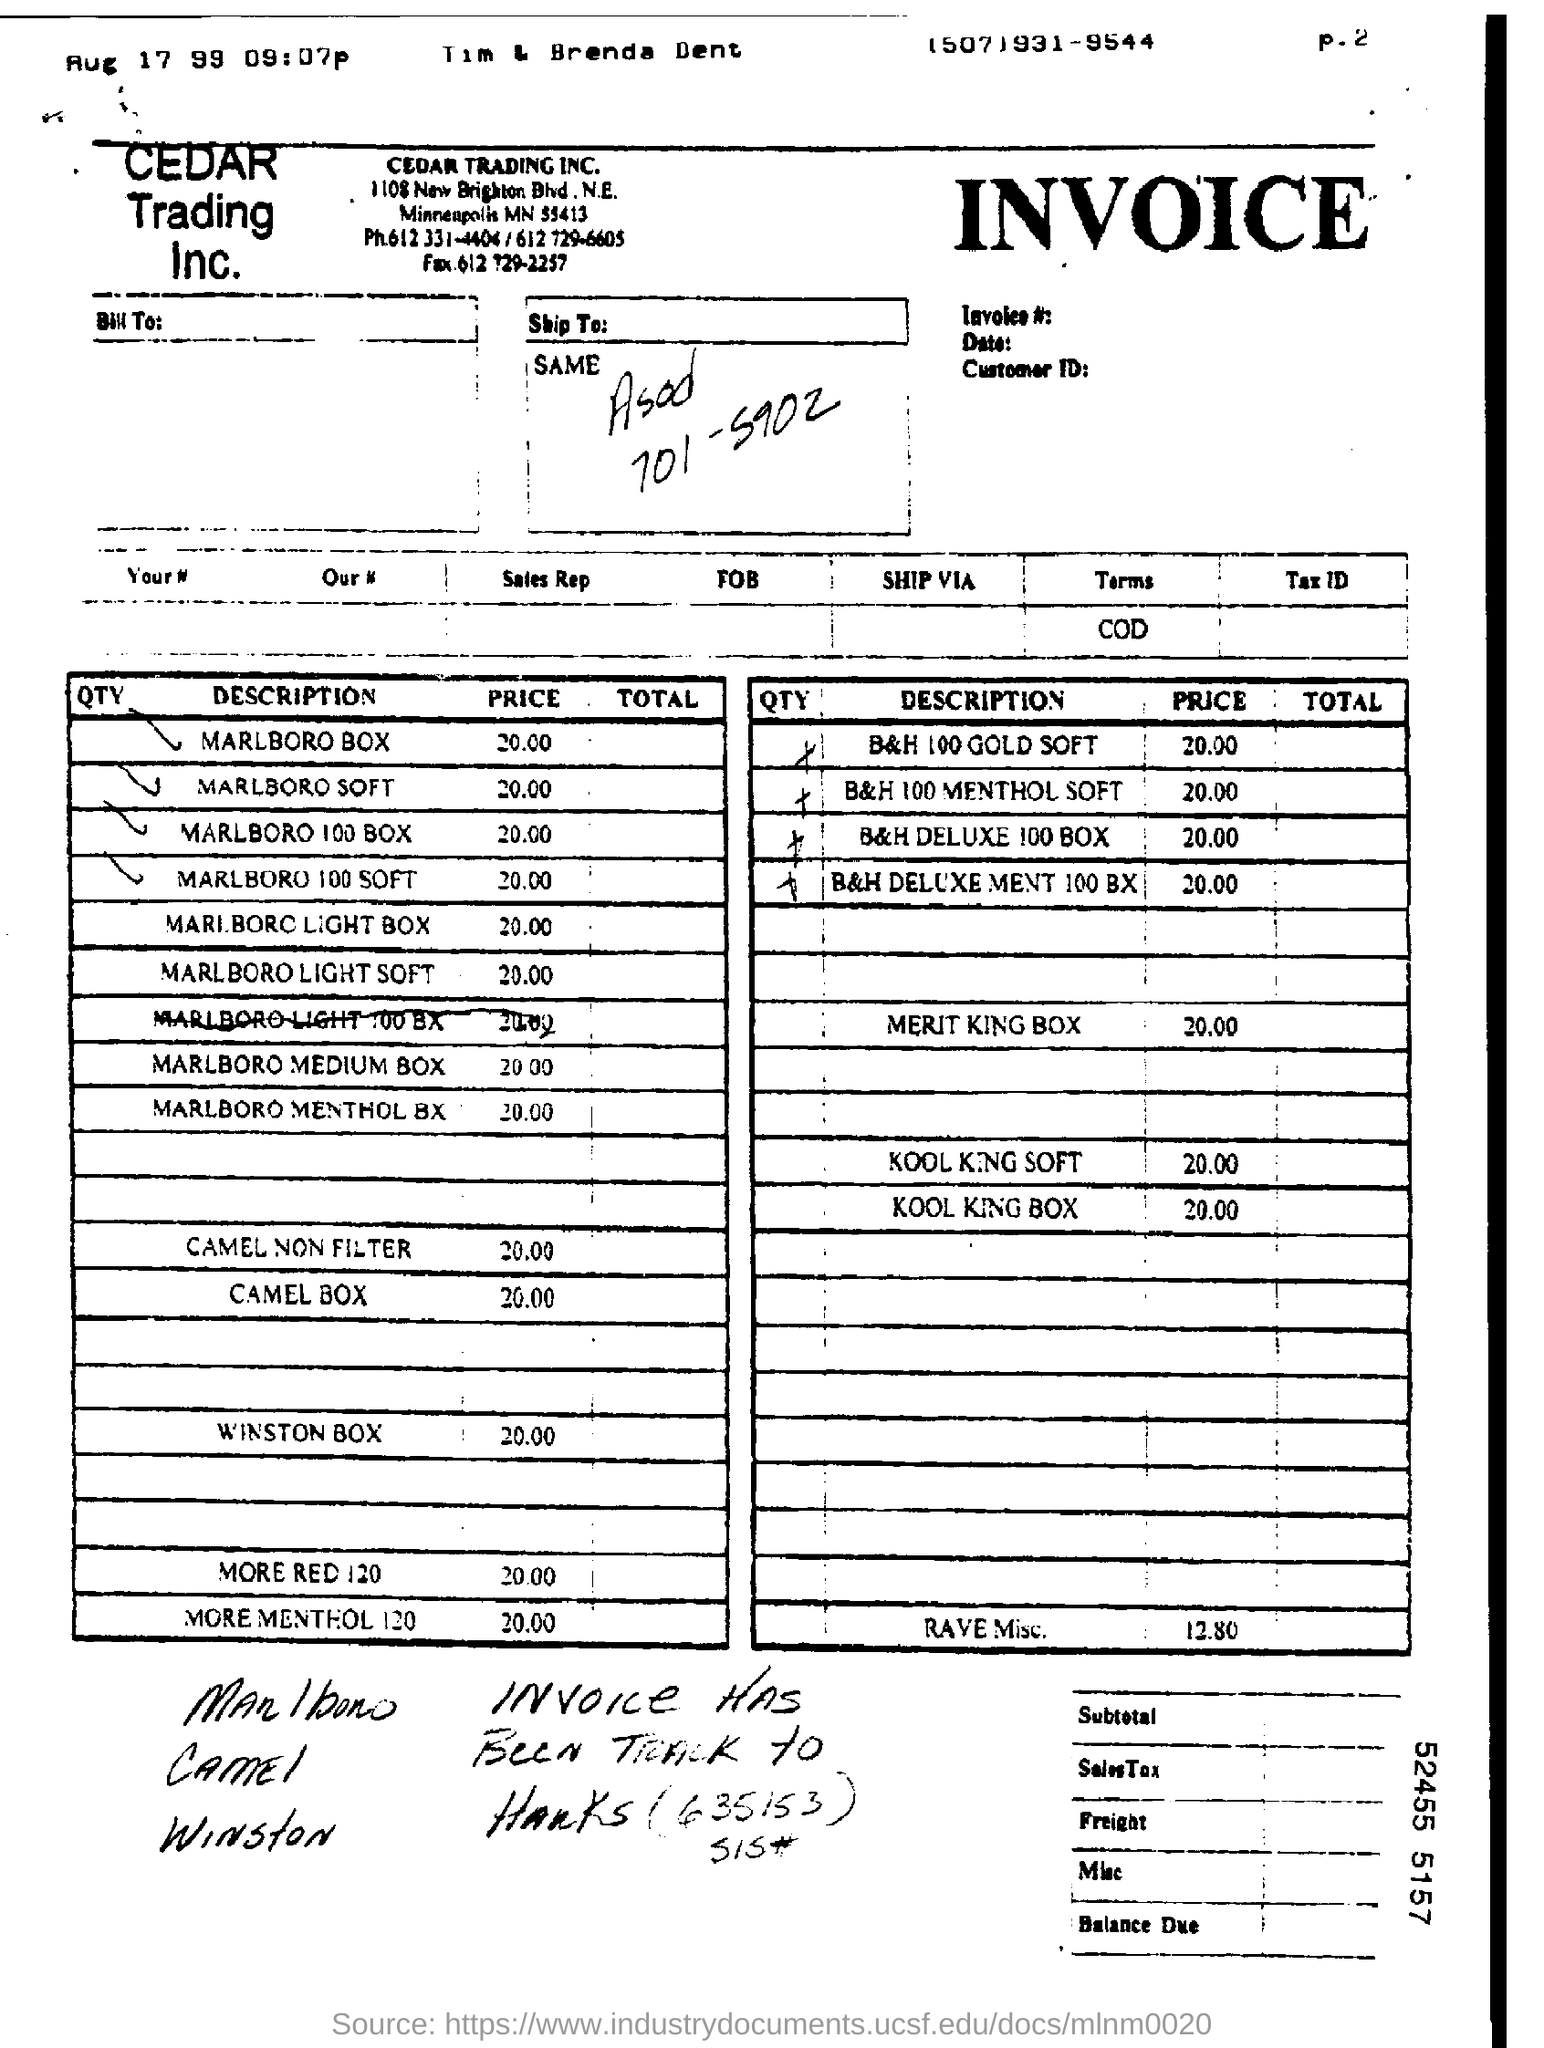What is the Price for B&H 100 GOLD SOFT?
Give a very brief answer. 20.00. What is the Price for Marlboro Box?
Keep it short and to the point. 20.00. What is the Price for Marlboro Soft?
Ensure brevity in your answer.  20.00. What is the Price for Marlboro 100 Box?
Provide a short and direct response. 20.00. What is the Price for Marlboro 100 soft?
Your answer should be very brief. 20.00. What is the Price for Marlboro Light Box?
Offer a very short reply. 20.00. What is the Price for Marlboro Light Soft?
Provide a succinct answer. 20.00. What is the Price for Marlboro Ligt 100 Bx?
Provide a short and direct response. 20.00. What is the Price for Marlboro Medium Box?
Make the answer very short. 20.00. What is the Price for Marlboro Menthol Box?
Your response must be concise. 20.00. 